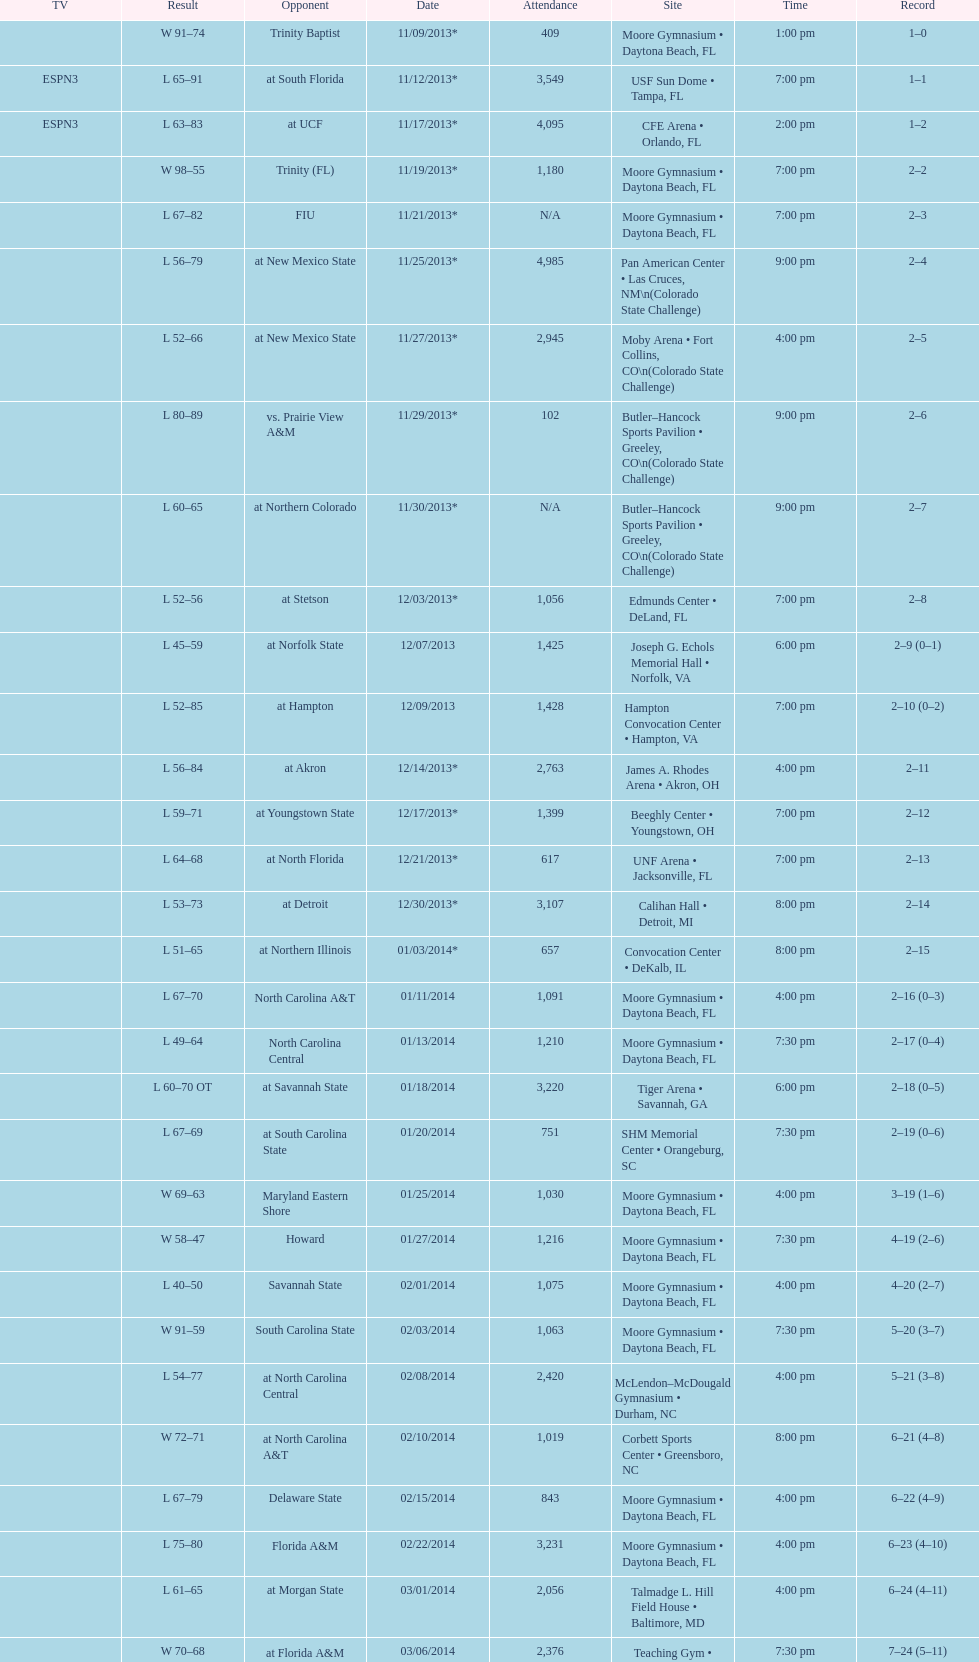How many teams had up to 1,000 attendees? 6. 